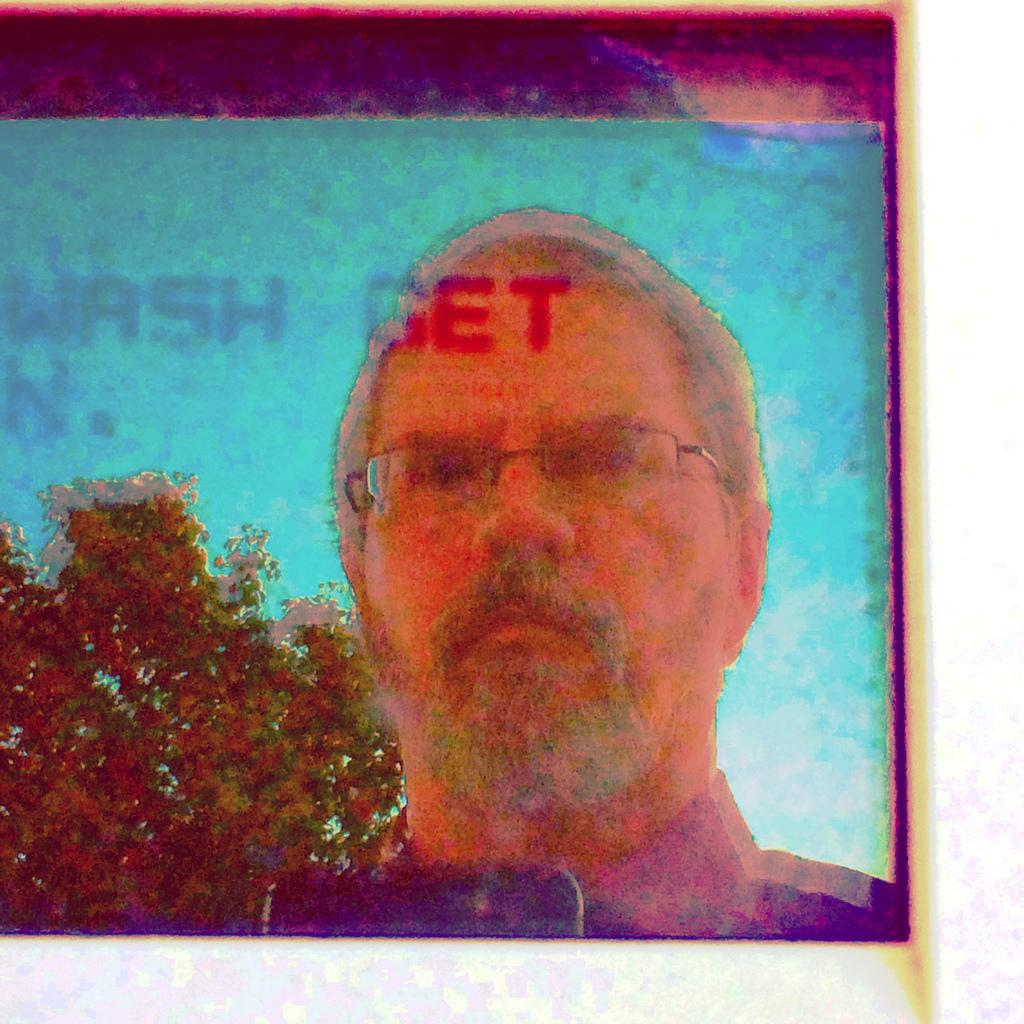Who is present in the image? There is a man in the image. What celestial object can be seen on the left side of the image? There is a planet visible on the left side of the image. What type of surprise is the man holding in the image? There is no surprise visible in the image; it only features a man and a planet. 